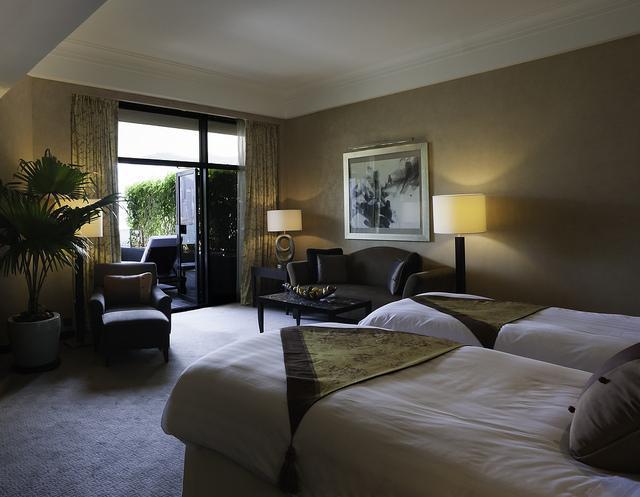How many beds in the room?
Give a very brief answer. 2. How many beds are there?
Give a very brief answer. 2. How many girl are there in the image?
Give a very brief answer. 0. 